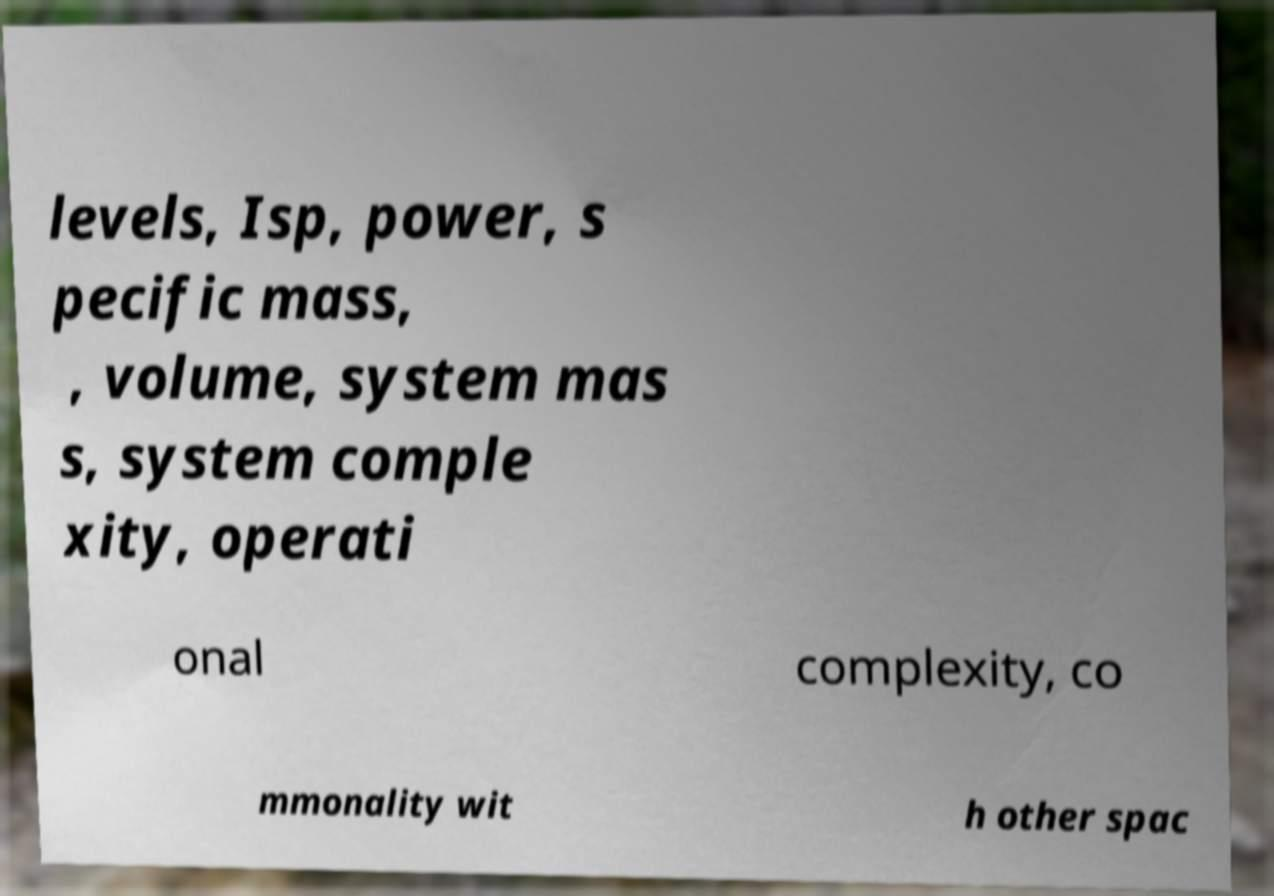Could you extract and type out the text from this image? levels, Isp, power, s pecific mass, , volume, system mas s, system comple xity, operati onal complexity, co mmonality wit h other spac 